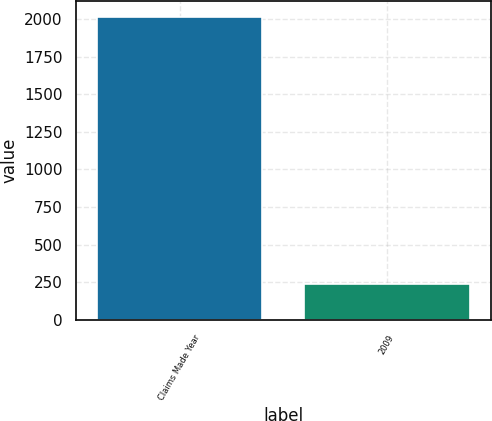<chart> <loc_0><loc_0><loc_500><loc_500><bar_chart><fcel>Claims Made Year<fcel>2009<nl><fcel>2018<fcel>238<nl></chart> 